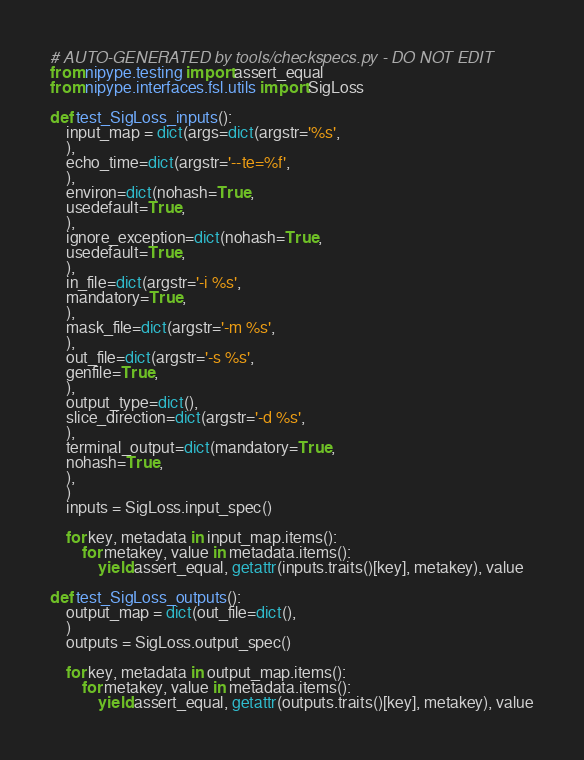Convert code to text. <code><loc_0><loc_0><loc_500><loc_500><_Python_># AUTO-GENERATED by tools/checkspecs.py - DO NOT EDIT
from nipype.testing import assert_equal
from nipype.interfaces.fsl.utils import SigLoss

def test_SigLoss_inputs():
    input_map = dict(args=dict(argstr='%s',
    ),
    echo_time=dict(argstr='--te=%f',
    ),
    environ=dict(nohash=True,
    usedefault=True,
    ),
    ignore_exception=dict(nohash=True,
    usedefault=True,
    ),
    in_file=dict(argstr='-i %s',
    mandatory=True,
    ),
    mask_file=dict(argstr='-m %s',
    ),
    out_file=dict(argstr='-s %s',
    genfile=True,
    ),
    output_type=dict(),
    slice_direction=dict(argstr='-d %s',
    ),
    terminal_output=dict(mandatory=True,
    nohash=True,
    ),
    )
    inputs = SigLoss.input_spec()

    for key, metadata in input_map.items():
        for metakey, value in metadata.items():
            yield assert_equal, getattr(inputs.traits()[key], metakey), value

def test_SigLoss_outputs():
    output_map = dict(out_file=dict(),
    )
    outputs = SigLoss.output_spec()

    for key, metadata in output_map.items():
        for metakey, value in metadata.items():
            yield assert_equal, getattr(outputs.traits()[key], metakey), value

</code> 